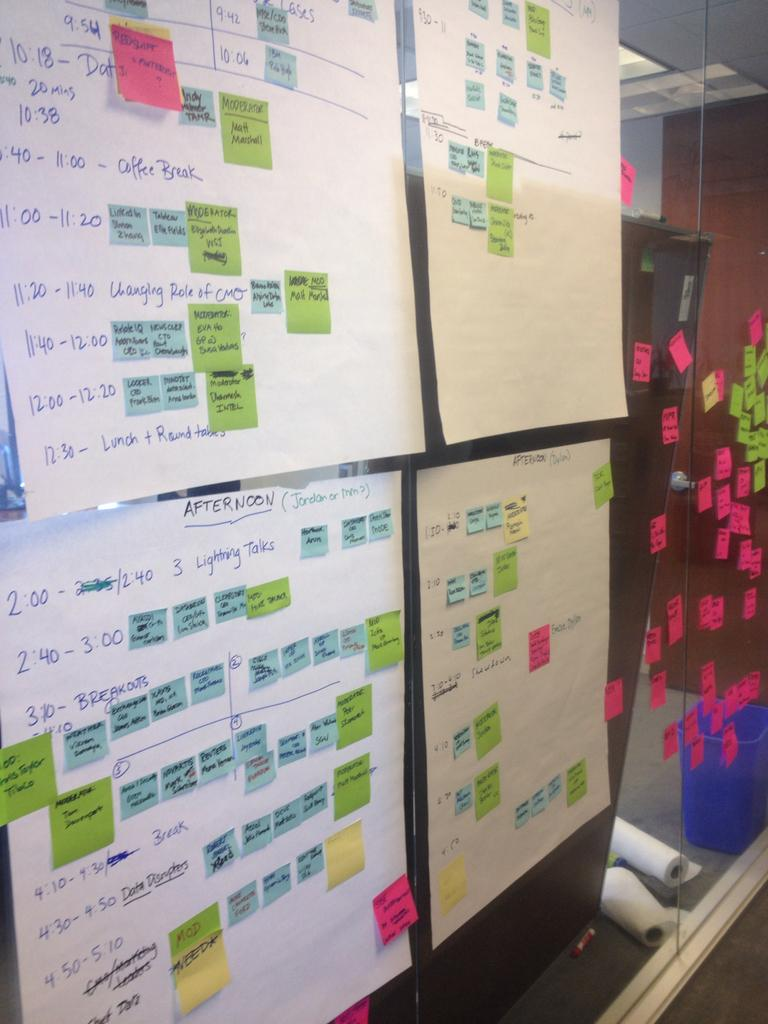<image>
Give a short and clear explanation of the subsequent image. papers hung on a wall with one that says 'afternoon' 